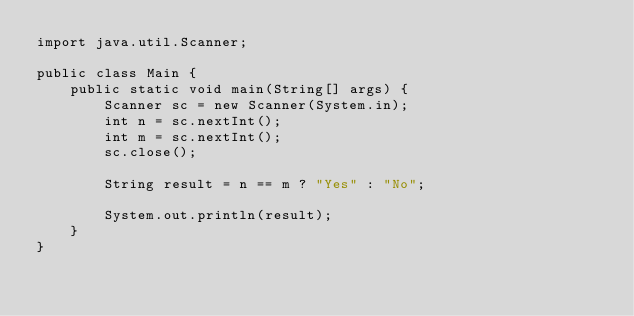<code> <loc_0><loc_0><loc_500><loc_500><_Java_>import java.util.Scanner;

public class Main {
	public static void main(String[] args) {
		Scanner sc = new Scanner(System.in);
		int n = sc.nextInt();
		int m = sc.nextInt();
		sc.close();

		String result = n == m ? "Yes" : "No";

		System.out.println(result);
	}
}
</code> 